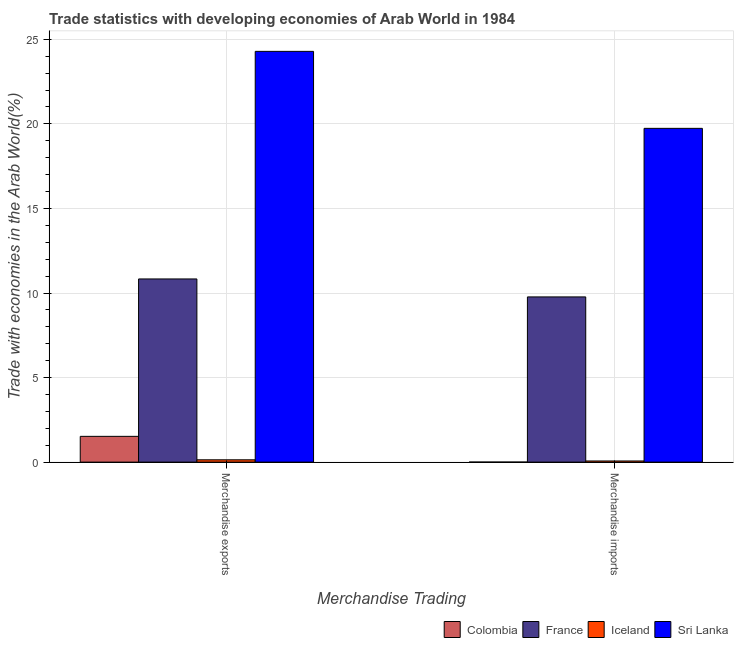How many groups of bars are there?
Make the answer very short. 2. Are the number of bars on each tick of the X-axis equal?
Offer a terse response. Yes. How many bars are there on the 1st tick from the right?
Keep it short and to the point. 4. What is the merchandise imports in Sri Lanka?
Ensure brevity in your answer.  19.74. Across all countries, what is the maximum merchandise imports?
Give a very brief answer. 19.74. Across all countries, what is the minimum merchandise exports?
Provide a short and direct response. 0.14. In which country was the merchandise exports maximum?
Offer a very short reply. Sri Lanka. What is the total merchandise imports in the graph?
Give a very brief answer. 29.57. What is the difference between the merchandise imports in Sri Lanka and that in France?
Offer a very short reply. 9.97. What is the difference between the merchandise exports in Sri Lanka and the merchandise imports in Colombia?
Keep it short and to the point. 24.29. What is the average merchandise imports per country?
Ensure brevity in your answer.  7.39. What is the difference between the merchandise imports and merchandise exports in Sri Lanka?
Provide a short and direct response. -4.55. What is the ratio of the merchandise exports in Sri Lanka to that in France?
Ensure brevity in your answer.  2.24. Is the merchandise imports in France less than that in Sri Lanka?
Offer a very short reply. Yes. What does the 4th bar from the left in Merchandise imports represents?
Your answer should be very brief. Sri Lanka. How many bars are there?
Your response must be concise. 8. Does the graph contain any zero values?
Provide a short and direct response. No. How many legend labels are there?
Offer a terse response. 4. How are the legend labels stacked?
Your response must be concise. Horizontal. What is the title of the graph?
Ensure brevity in your answer.  Trade statistics with developing economies of Arab World in 1984. What is the label or title of the X-axis?
Make the answer very short. Merchandise Trading. What is the label or title of the Y-axis?
Your answer should be compact. Trade with economies in the Arab World(%). What is the Trade with economies in the Arab World(%) in Colombia in Merchandise exports?
Ensure brevity in your answer.  1.52. What is the Trade with economies in the Arab World(%) of France in Merchandise exports?
Your answer should be very brief. 10.83. What is the Trade with economies in the Arab World(%) in Iceland in Merchandise exports?
Your response must be concise. 0.14. What is the Trade with economies in the Arab World(%) of Sri Lanka in Merchandise exports?
Offer a terse response. 24.29. What is the Trade with economies in the Arab World(%) in Colombia in Merchandise imports?
Give a very brief answer. 0. What is the Trade with economies in the Arab World(%) in France in Merchandise imports?
Your response must be concise. 9.77. What is the Trade with economies in the Arab World(%) of Iceland in Merchandise imports?
Provide a succinct answer. 0.07. What is the Trade with economies in the Arab World(%) in Sri Lanka in Merchandise imports?
Provide a short and direct response. 19.74. Across all Merchandise Trading, what is the maximum Trade with economies in the Arab World(%) in Colombia?
Provide a succinct answer. 1.52. Across all Merchandise Trading, what is the maximum Trade with economies in the Arab World(%) of France?
Provide a succinct answer. 10.83. Across all Merchandise Trading, what is the maximum Trade with economies in the Arab World(%) in Iceland?
Give a very brief answer. 0.14. Across all Merchandise Trading, what is the maximum Trade with economies in the Arab World(%) in Sri Lanka?
Make the answer very short. 24.29. Across all Merchandise Trading, what is the minimum Trade with economies in the Arab World(%) of Colombia?
Provide a short and direct response. 0. Across all Merchandise Trading, what is the minimum Trade with economies in the Arab World(%) in France?
Offer a terse response. 9.77. Across all Merchandise Trading, what is the minimum Trade with economies in the Arab World(%) in Iceland?
Your answer should be compact. 0.07. Across all Merchandise Trading, what is the minimum Trade with economies in the Arab World(%) in Sri Lanka?
Give a very brief answer. 19.74. What is the total Trade with economies in the Arab World(%) of Colombia in the graph?
Your answer should be compact. 1.52. What is the total Trade with economies in the Arab World(%) in France in the graph?
Offer a terse response. 20.6. What is the total Trade with economies in the Arab World(%) of Iceland in the graph?
Provide a short and direct response. 0.2. What is the total Trade with economies in the Arab World(%) in Sri Lanka in the graph?
Make the answer very short. 44.02. What is the difference between the Trade with economies in the Arab World(%) in Colombia in Merchandise exports and that in Merchandise imports?
Your response must be concise. 1.52. What is the difference between the Trade with economies in the Arab World(%) of France in Merchandise exports and that in Merchandise imports?
Ensure brevity in your answer.  1.06. What is the difference between the Trade with economies in the Arab World(%) in Iceland in Merchandise exports and that in Merchandise imports?
Provide a short and direct response. 0.07. What is the difference between the Trade with economies in the Arab World(%) of Sri Lanka in Merchandise exports and that in Merchandise imports?
Your answer should be very brief. 4.55. What is the difference between the Trade with economies in the Arab World(%) of Colombia in Merchandise exports and the Trade with economies in the Arab World(%) of France in Merchandise imports?
Offer a very short reply. -8.25. What is the difference between the Trade with economies in the Arab World(%) of Colombia in Merchandise exports and the Trade with economies in the Arab World(%) of Iceland in Merchandise imports?
Offer a terse response. 1.46. What is the difference between the Trade with economies in the Arab World(%) of Colombia in Merchandise exports and the Trade with economies in the Arab World(%) of Sri Lanka in Merchandise imports?
Provide a succinct answer. -18.21. What is the difference between the Trade with economies in the Arab World(%) of France in Merchandise exports and the Trade with economies in the Arab World(%) of Iceland in Merchandise imports?
Your response must be concise. 10.76. What is the difference between the Trade with economies in the Arab World(%) of France in Merchandise exports and the Trade with economies in the Arab World(%) of Sri Lanka in Merchandise imports?
Provide a succinct answer. -8.9. What is the difference between the Trade with economies in the Arab World(%) in Iceland in Merchandise exports and the Trade with economies in the Arab World(%) in Sri Lanka in Merchandise imports?
Provide a succinct answer. -19.6. What is the average Trade with economies in the Arab World(%) in Colombia per Merchandise Trading?
Your answer should be very brief. 0.76. What is the average Trade with economies in the Arab World(%) in Iceland per Merchandise Trading?
Keep it short and to the point. 0.1. What is the average Trade with economies in the Arab World(%) in Sri Lanka per Merchandise Trading?
Provide a succinct answer. 22.01. What is the difference between the Trade with economies in the Arab World(%) of Colombia and Trade with economies in the Arab World(%) of France in Merchandise exports?
Your answer should be compact. -9.31. What is the difference between the Trade with economies in the Arab World(%) of Colombia and Trade with economies in the Arab World(%) of Iceland in Merchandise exports?
Provide a short and direct response. 1.39. What is the difference between the Trade with economies in the Arab World(%) of Colombia and Trade with economies in the Arab World(%) of Sri Lanka in Merchandise exports?
Keep it short and to the point. -22.76. What is the difference between the Trade with economies in the Arab World(%) of France and Trade with economies in the Arab World(%) of Iceland in Merchandise exports?
Give a very brief answer. 10.69. What is the difference between the Trade with economies in the Arab World(%) in France and Trade with economies in the Arab World(%) in Sri Lanka in Merchandise exports?
Give a very brief answer. -13.46. What is the difference between the Trade with economies in the Arab World(%) in Iceland and Trade with economies in the Arab World(%) in Sri Lanka in Merchandise exports?
Make the answer very short. -24.15. What is the difference between the Trade with economies in the Arab World(%) of Colombia and Trade with economies in the Arab World(%) of France in Merchandise imports?
Provide a succinct answer. -9.77. What is the difference between the Trade with economies in the Arab World(%) in Colombia and Trade with economies in the Arab World(%) in Iceland in Merchandise imports?
Keep it short and to the point. -0.07. What is the difference between the Trade with economies in the Arab World(%) of Colombia and Trade with economies in the Arab World(%) of Sri Lanka in Merchandise imports?
Your answer should be very brief. -19.73. What is the difference between the Trade with economies in the Arab World(%) of France and Trade with economies in the Arab World(%) of Iceland in Merchandise imports?
Make the answer very short. 9.7. What is the difference between the Trade with economies in the Arab World(%) in France and Trade with economies in the Arab World(%) in Sri Lanka in Merchandise imports?
Your response must be concise. -9.97. What is the difference between the Trade with economies in the Arab World(%) in Iceland and Trade with economies in the Arab World(%) in Sri Lanka in Merchandise imports?
Your answer should be very brief. -19.67. What is the ratio of the Trade with economies in the Arab World(%) of Colombia in Merchandise exports to that in Merchandise imports?
Keep it short and to the point. 1140.69. What is the ratio of the Trade with economies in the Arab World(%) of France in Merchandise exports to that in Merchandise imports?
Provide a succinct answer. 1.11. What is the ratio of the Trade with economies in the Arab World(%) in Iceland in Merchandise exports to that in Merchandise imports?
Give a very brief answer. 2.01. What is the ratio of the Trade with economies in the Arab World(%) of Sri Lanka in Merchandise exports to that in Merchandise imports?
Provide a succinct answer. 1.23. What is the difference between the highest and the second highest Trade with economies in the Arab World(%) in Colombia?
Ensure brevity in your answer.  1.52. What is the difference between the highest and the second highest Trade with economies in the Arab World(%) of France?
Offer a very short reply. 1.06. What is the difference between the highest and the second highest Trade with economies in the Arab World(%) in Iceland?
Offer a very short reply. 0.07. What is the difference between the highest and the second highest Trade with economies in the Arab World(%) in Sri Lanka?
Give a very brief answer. 4.55. What is the difference between the highest and the lowest Trade with economies in the Arab World(%) in Colombia?
Provide a succinct answer. 1.52. What is the difference between the highest and the lowest Trade with economies in the Arab World(%) of France?
Offer a very short reply. 1.06. What is the difference between the highest and the lowest Trade with economies in the Arab World(%) of Iceland?
Give a very brief answer. 0.07. What is the difference between the highest and the lowest Trade with economies in the Arab World(%) in Sri Lanka?
Give a very brief answer. 4.55. 